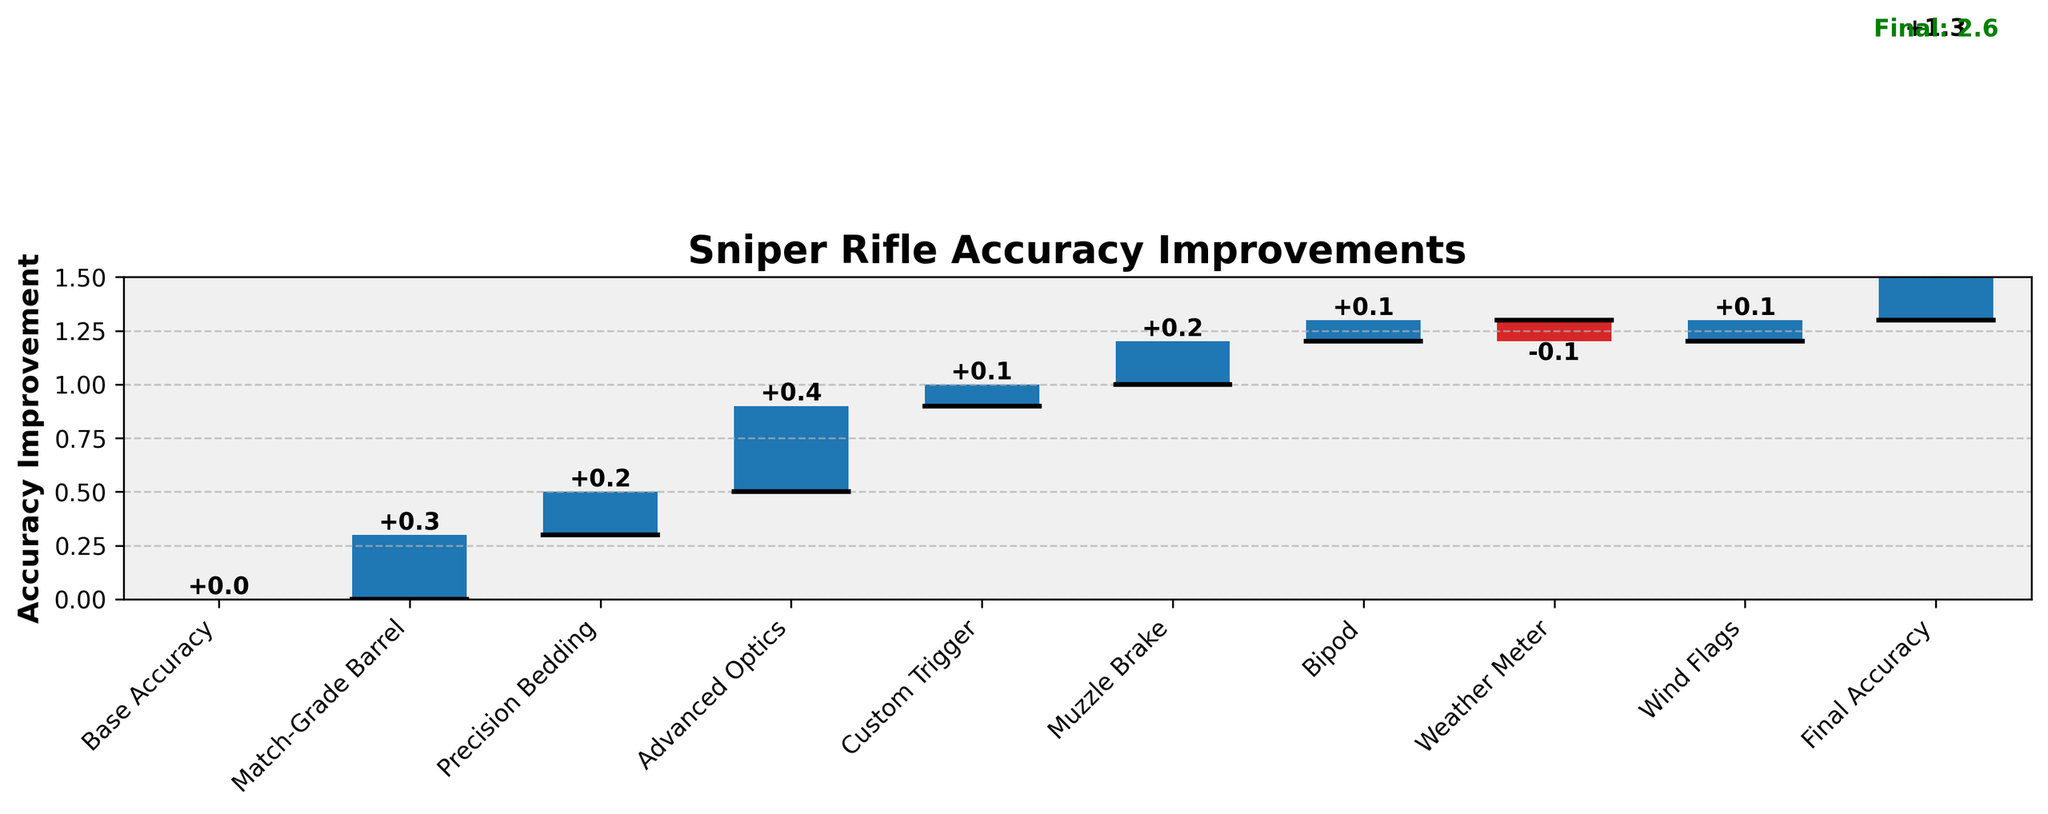What is the title of the graph? The title is usually located at the top of the graph. In this graph, it reads "Sniper Rifle Accuracy Improvements".
Answer: Sniper Rifle Accuracy Improvements How many categories are listed in the x-axis labels? The x-axis labels typically mark each category involved in modifying the sniper rifle. By counting the labels, we find that there are ten categories listed.
Answer: 10 What is the cumulative effect of adding an Advanced Optics on the sniper rifle's accuracy? To find this, track the cumulative sum up to the Advanced Optics category. Since previous modifications add up to 0.5 (Base Accuracy + Match-Grade Barrel + Precision Bedding = 0 + 0.3 + 0.2 = 0.5), adding Advanced Optics (+0.4) results in a cumulative sum of 0.9.
Answer: 0.9 Which modification has a negative impact on the sniper rifle's accuracy? The color coding indicates negative values in red. By looking at the bar graph, only the Weather Meter category shows a red bar, indicating a negative impact.
Answer: Weather Meter What is the net improvement in accuracy from Precision Bedding and Custom Trigger modifications combined? To determine the net improvement, sum the values associated with Precision Bedding (+0.2) and Custom Trigger (+0.1). The combined improvement is thus 0.2 + 0.1.
Answer: 0.3 Which modification contributes the most to the sniper rifle's accuracy improvement? By examining the heights of the bars representing improvements, the tallest bar corresponds to Advanced Optics, which contributes +0.4 to accuracy improvement.
Answer: Advanced Optics Compare the impacts of the Bipod and Wind Flags modifications. Which one is greater? By comparing the heights of these two bars, both the Bipod and Wind Flags modifications have the same value (+0.1).
Answer: Equal What is the final accuracy improvement of the sniper rifle after all modifications? The final accuracy is indicated by the last cumulative value on the graph, which is given as 1.3.
Answer: 1.3 How does the Match-Grade Barrel modification affect the initial base accuracy? Examine the first step from the base accuracy (0) following the modification. The Match-Grade Barrel adds +0.3 to the base accuracy.
Answer: +0.3 If you exclude the Weather Meter's negative impact, what would be the final accuracy improvement? Calculate the final accuracy without the -0.1 from the Weather Meter. The final listed accuracy is 1.3, so adding back 0.1 results in 1.4.
Answer: 1.4 